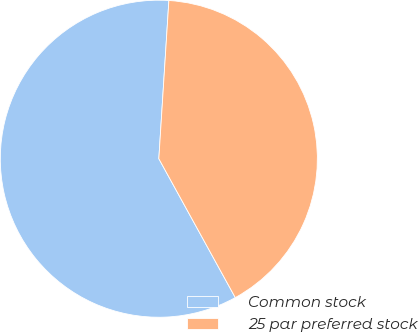Convert chart. <chart><loc_0><loc_0><loc_500><loc_500><pie_chart><fcel>Common stock<fcel>25 par preferred stock<nl><fcel>59.02%<fcel>40.98%<nl></chart> 